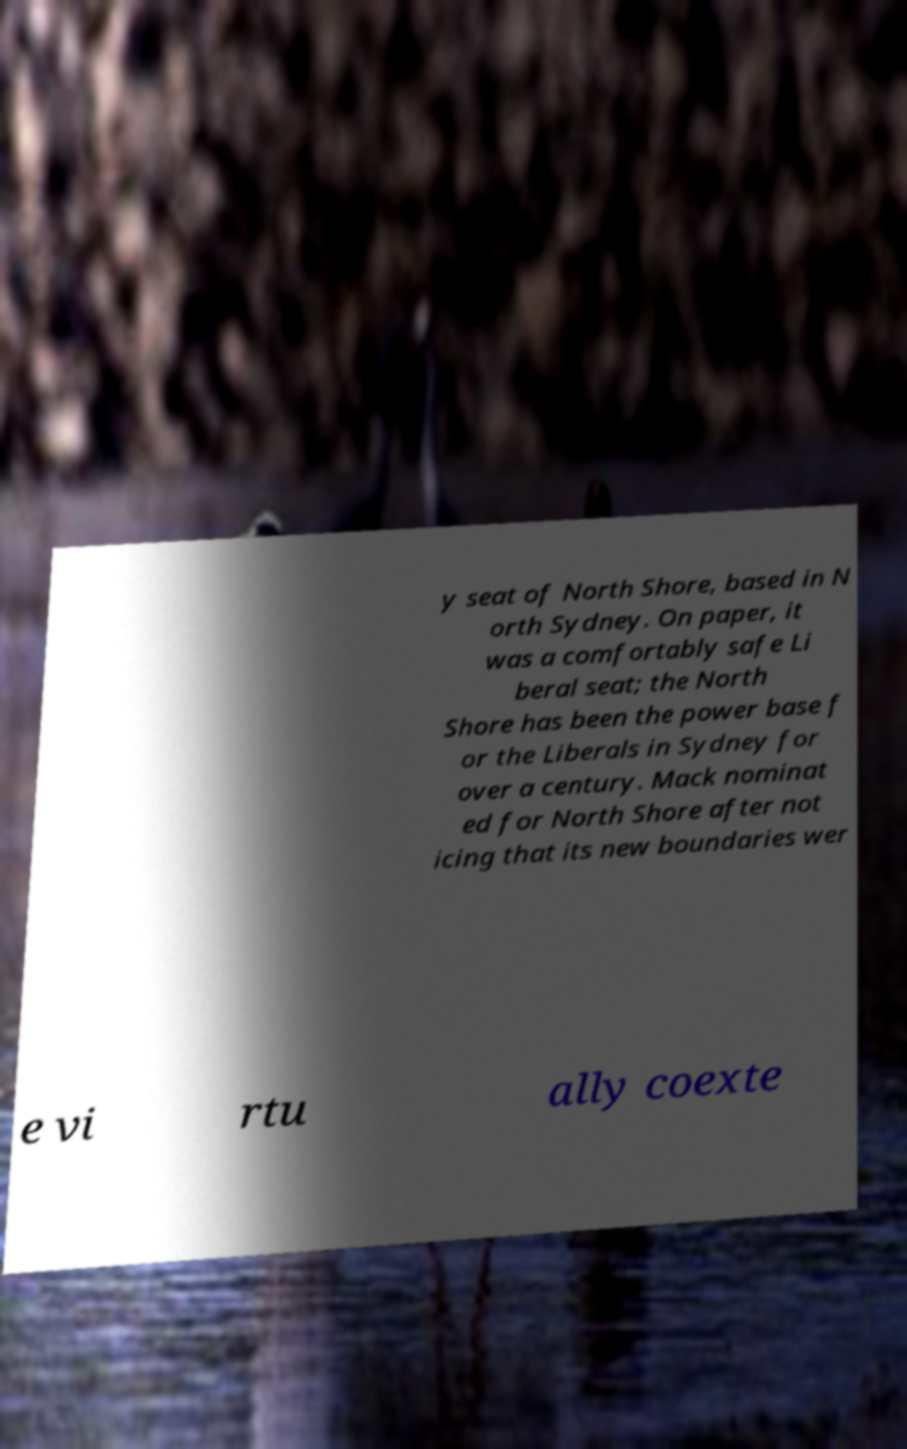What messages or text are displayed in this image? I need them in a readable, typed format. y seat of North Shore, based in N orth Sydney. On paper, it was a comfortably safe Li beral seat; the North Shore has been the power base f or the Liberals in Sydney for over a century. Mack nominat ed for North Shore after not icing that its new boundaries wer e vi rtu ally coexte 